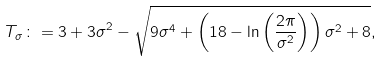Convert formula to latex. <formula><loc_0><loc_0><loc_500><loc_500>T _ { \sigma } \colon = 3 + 3 \sigma ^ { 2 } - \sqrt { 9 \sigma ^ { 4 } + \left ( 1 8 - \ln \left ( \frac { 2 \pi } { \sigma ^ { 2 } } \right ) \right ) \sigma ^ { 2 } + 8 } ,</formula> 